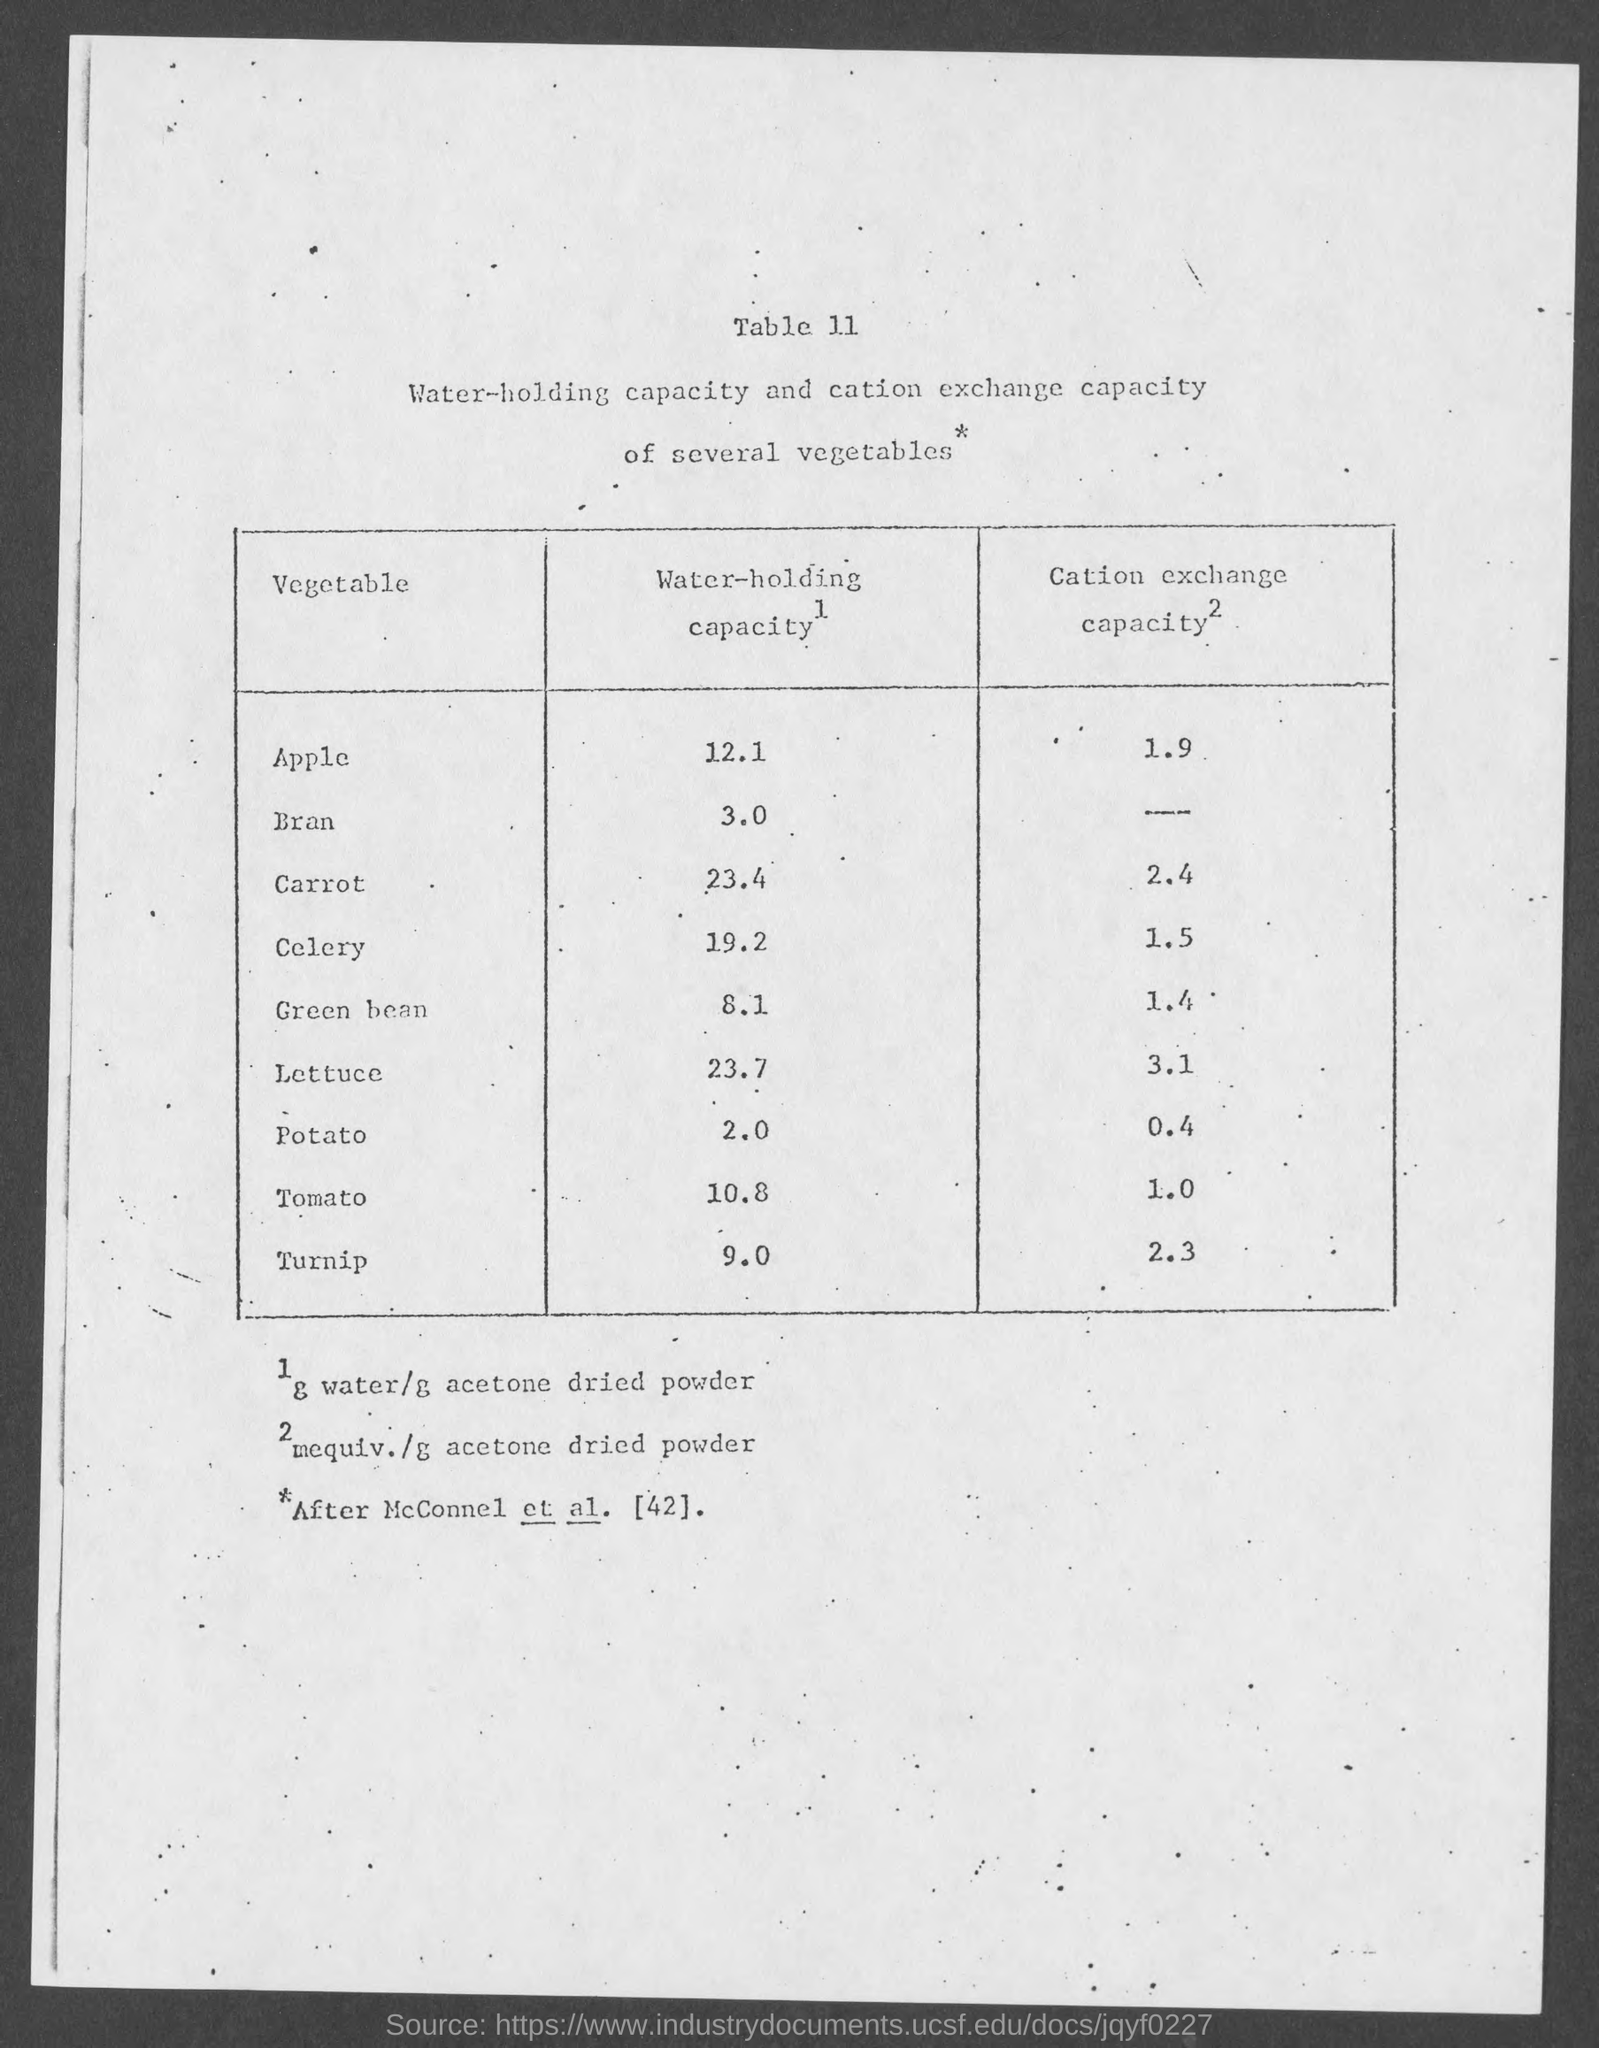Outline some significant characteristics in this image. The water holding capacity of celery is 19.2%. The water-holding capacity of bran is 3.0... The cation exchange capacity for green beans is 1.4. The cation exchange capacity of apples is approximately 1.9. The water-holding capacity of turnip is 9.0. 